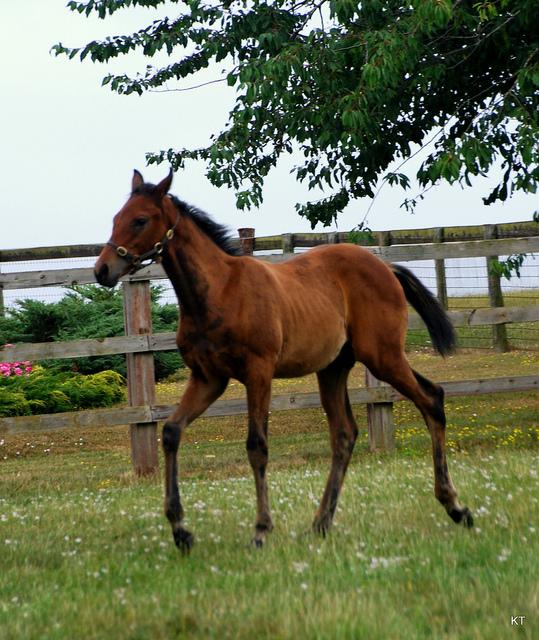What breed of horse is this?
Quick response, please. Thoroughbred. Does this horse look healthy?
Keep it brief. No. Is this horse in a corral?
Concise answer only. Yes. 